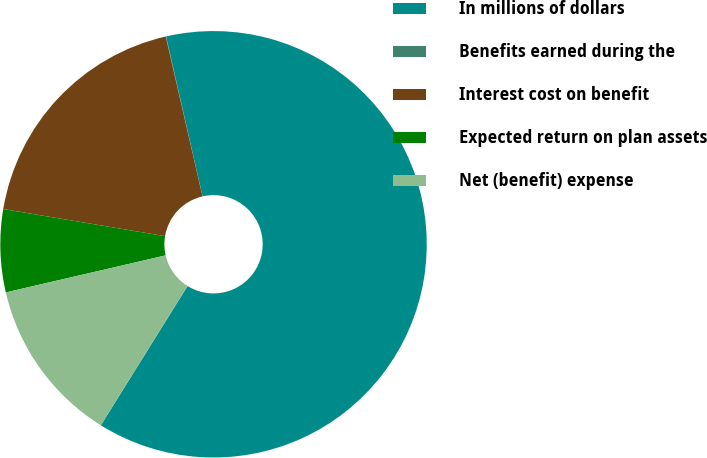Convert chart. <chart><loc_0><loc_0><loc_500><loc_500><pie_chart><fcel>In millions of dollars<fcel>Benefits earned during the<fcel>Interest cost on benefit<fcel>Expected return on plan assets<fcel>Net (benefit) expense<nl><fcel>62.43%<fcel>0.03%<fcel>18.75%<fcel>6.27%<fcel>12.51%<nl></chart> 